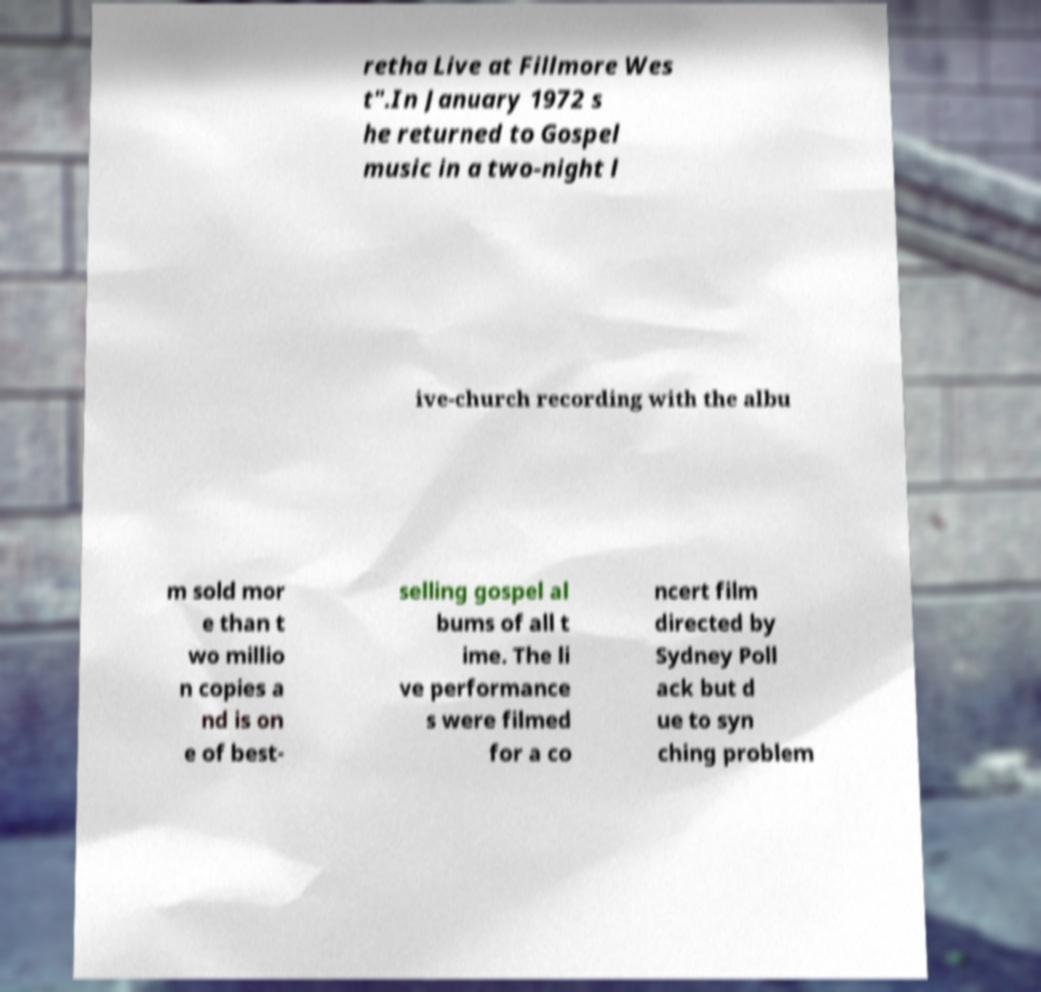Can you accurately transcribe the text from the provided image for me? retha Live at Fillmore Wes t".In January 1972 s he returned to Gospel music in a two-night l ive-church recording with the albu m sold mor e than t wo millio n copies a nd is on e of best- selling gospel al bums of all t ime. The li ve performance s were filmed for a co ncert film directed by Sydney Poll ack but d ue to syn ching problem 